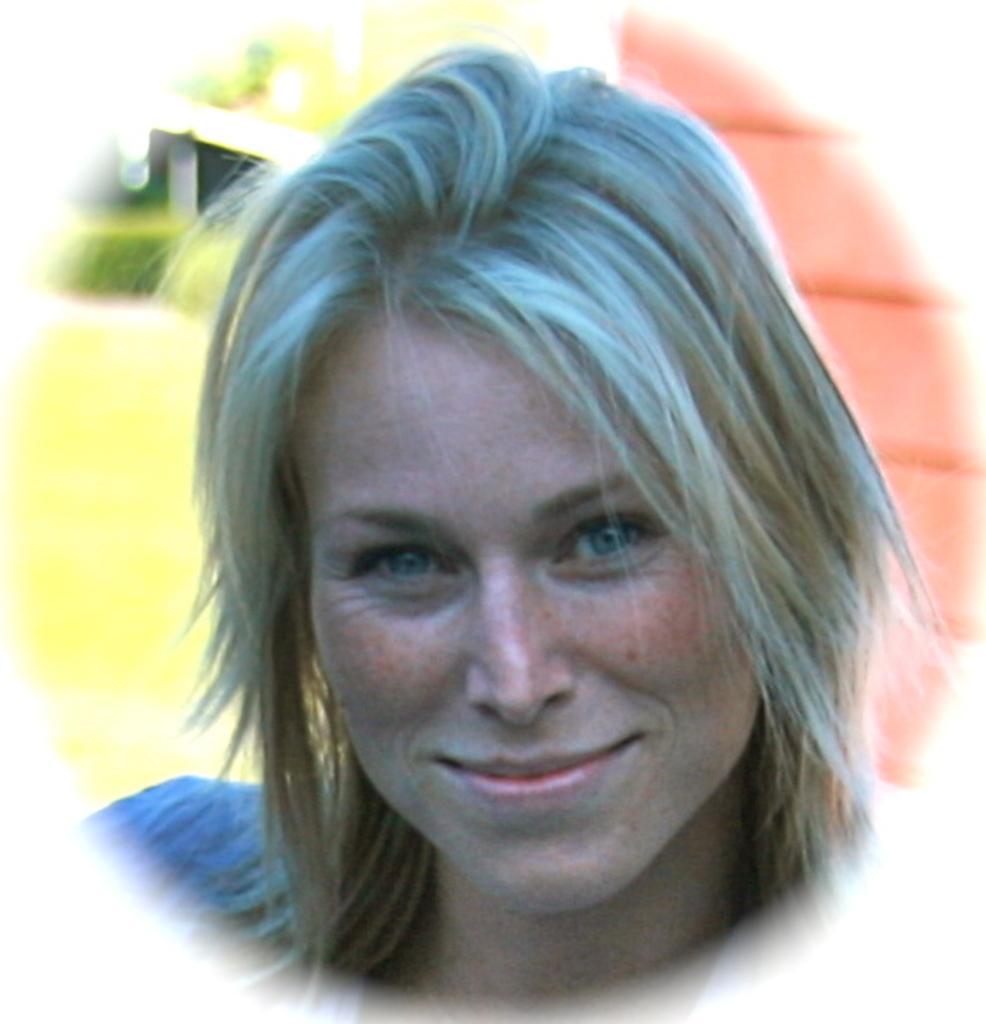Describe this image in one or two sentences. In the image there is a lady smiling. Behind her there is a blur background with a wall. 